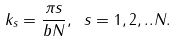<formula> <loc_0><loc_0><loc_500><loc_500>k _ { s } = \frac { \pi s } { b N } , \ s = 1 , 2 , . . N .</formula> 